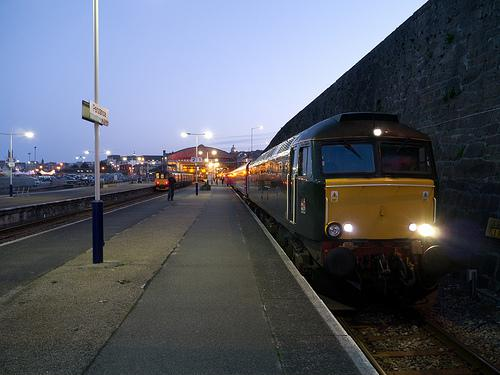Question: when was this picture taken?
Choices:
A. Midnight.
B. Noon.
C. Morning.
D. At dusk.
Answer with the letter. Answer: D Question: where was this picture taken?
Choices:
A. A train station platform.
B. The mall.
C. The airport.
D. Park.
Answer with the letter. Answer: A Question: what is to the right of the train?
Choices:
A. A fence.
B. A wall.
C. Another train.
D. People.
Answer with the letter. Answer: B Question: how many lights are working on the front of the train?
Choices:
A. One.
B. None.
C. Two.
D. Four.
Answer with the letter. Answer: D Question: why are the streetlights on?
Choices:
A. Waste electricity.
B. Decoration.
C. Film set.
D. It is dark.
Answer with the letter. Answer: D 